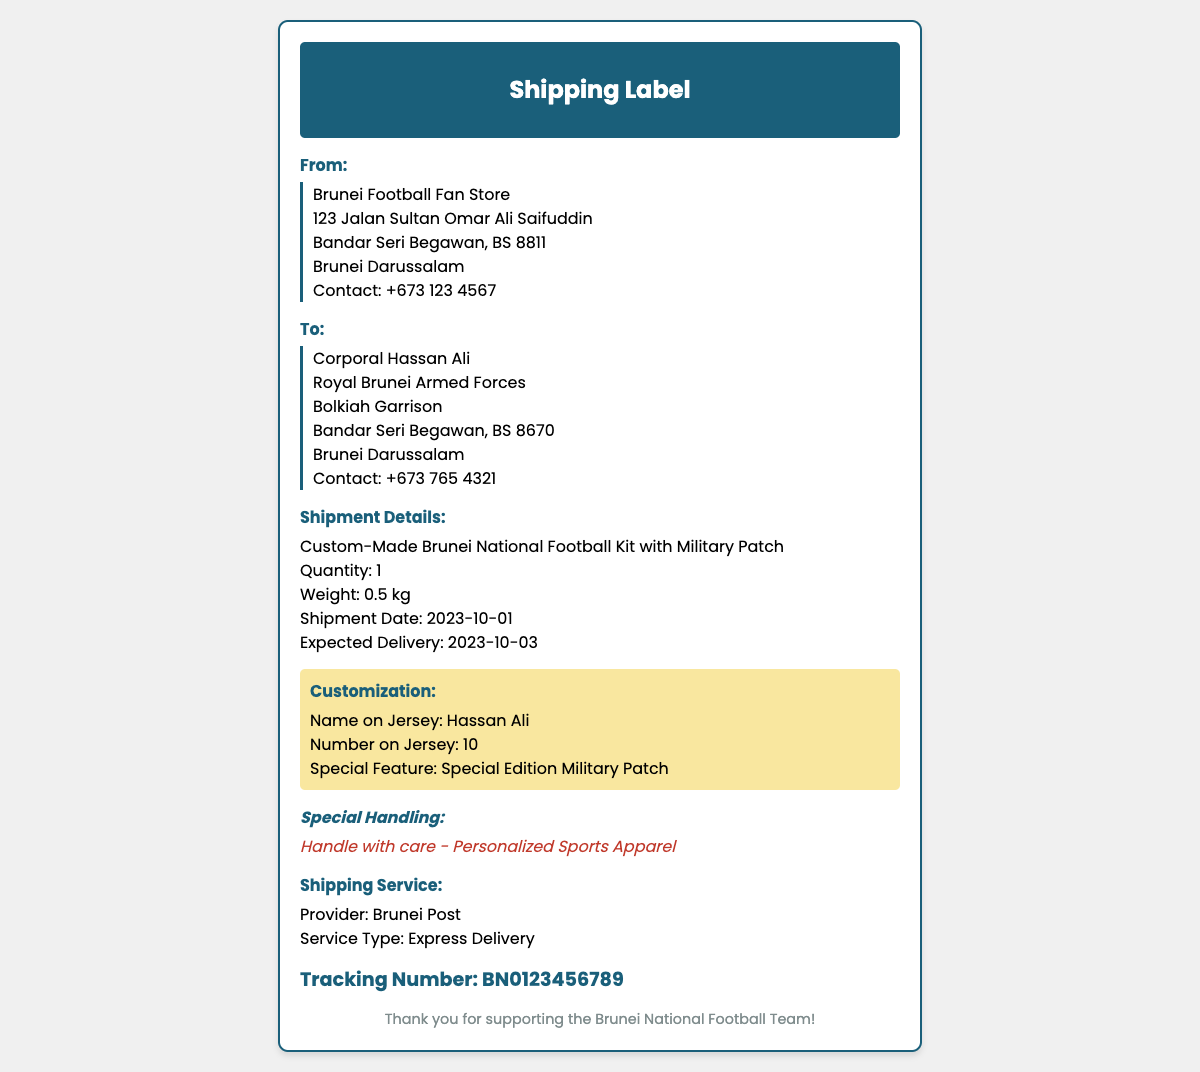What is the sender's name? The sender's name is found in the "From" section of the document.
Answer: Brunei Football Fan Store Who is the recipient? The recipient's name is given in the "To" section of the document.
Answer: Corporal Hassan Ali What is the expected delivery date? The expected delivery date is noted in the shipment details section.
Answer: 2023-10-03 What is the weight of the parcel? The weight detail is provided in the shipment details section.
Answer: 0.5 kg What is the quantity of the shipment? The quantity is listed in the shipment details section.
Answer: 1 What is the special feature of the kit? The special feature is specified in the customization section of the document.
Answer: Special Edition Military Patch Which shipping provider is mentioned? The shipping provider's name can be found in the shipping service section.
Answer: Brunei Post What is the service type for shipping? The type of service is indicated under the shipping service section.
Answer: Express Delivery What special handling instructions are given? Special handling instructions are mentioned in the special instructions section.
Answer: Handle with care - Personalized Sports Apparel What is the tracking number? The tracking information is located at the bottom of the document.
Answer: BN0123456789 